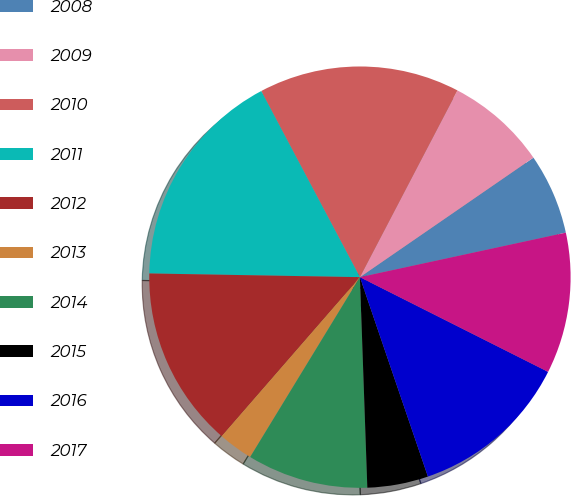Convert chart. <chart><loc_0><loc_0><loc_500><loc_500><pie_chart><fcel>2008<fcel>2009<fcel>2010<fcel>2011<fcel>2012<fcel>2013<fcel>2014<fcel>2015<fcel>2016<fcel>2017<nl><fcel>6.21%<fcel>7.74%<fcel>15.42%<fcel>16.96%<fcel>13.89%<fcel>2.67%<fcel>9.28%<fcel>4.67%<fcel>12.35%<fcel>10.81%<nl></chart> 